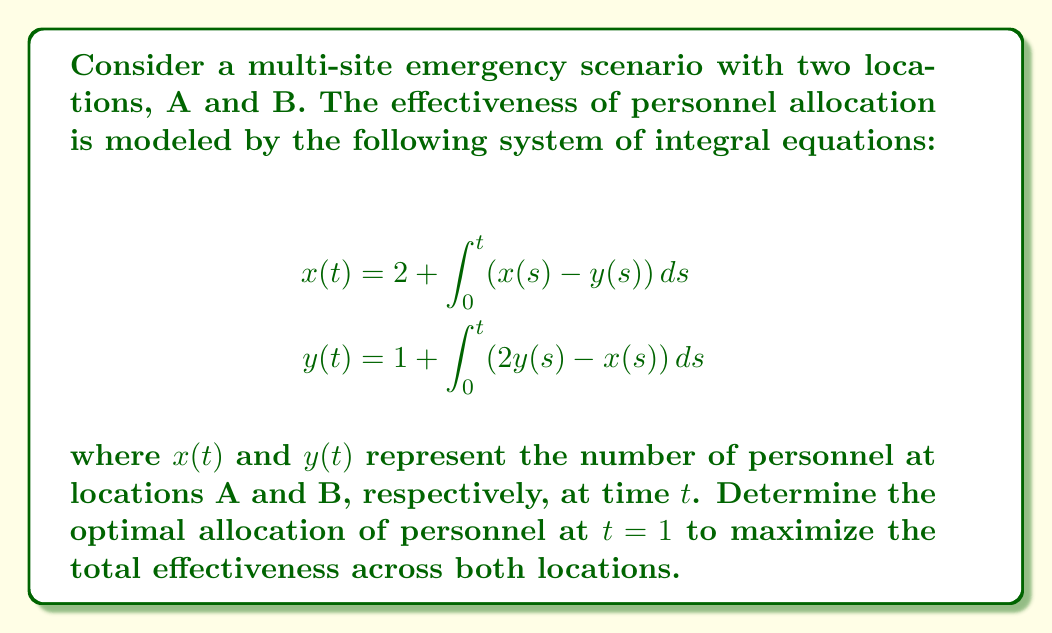Provide a solution to this math problem. To solve this system of integral equations and find the optimal allocation at $t=1$, we'll follow these steps:

1) First, differentiate both equations with respect to $t$:
   $$\begin{aligned}
   x'(t) &= x(t) - y(t) \\
   y'(t) &= 2y(t) - x(t)
   \end{aligned}$$

2) This gives us a system of differential equations. We can solve it by finding the eigenvalues and eigenvectors of the coefficient matrix:
   $$A = \begin{pmatrix} 1 & -1 \\ -1 & 2 \end{pmatrix}$$

3) The characteristic equation is:
   $$\det(A - \lambda I) = (1-\lambda)(2-\lambda) - 1 = \lambda^2 - 3\lambda + 1 = 0$$

4) Solving this, we get eigenvalues:
   $$\lambda_1 = \frac{3 + \sqrt{5}}{2}, \quad \lambda_2 = \frac{3 - \sqrt{5}}{2}$$

5) The corresponding eigenvectors are:
   $$v_1 = \begin{pmatrix} \frac{1+\sqrt{5}}{2} \\ 1 \end{pmatrix}, \quad v_2 = \begin{pmatrix} \frac{1-\sqrt{5}}{2} \\ 1 \end{pmatrix}$$

6) The general solution is:
   $$\begin{pmatrix} x(t) \\ y(t) \end{pmatrix} = c_1e^{\lambda_1t}v_1 + c_2e^{\lambda_2t}v_2$$

7) Using the initial conditions $x(0) = 2$ and $y(0) = 1$, we can solve for $c_1$ and $c_2$:
   $$c_1 = \frac{3+\sqrt{5}}{2\sqrt{5}}, \quad c_2 = \frac{3-\sqrt{5}}{2\sqrt{5}}$$

8) Therefore, the solution at $t=1$ is:
   $$\begin{aligned}
   x(1) &= c_1e^{\lambda_1}\frac{1+\sqrt{5}}{2} + c_2e^{\lambda_2}\frac{1-\sqrt{5}}{2} \\
   y(1) &= c_1e^{\lambda_1} + c_2e^{\lambda_2}
   \end{aligned}$$

9) Calculating these values:
   $$x(1) \approx 3.30, \quad y(1) \approx 2.18$$

10) The total effectiveness is maximized when the sum $x(1) + y(1)$ is maximized, which occurs at these values.
Answer: $x(1) \approx 3.30, y(1) \approx 2.18$ 